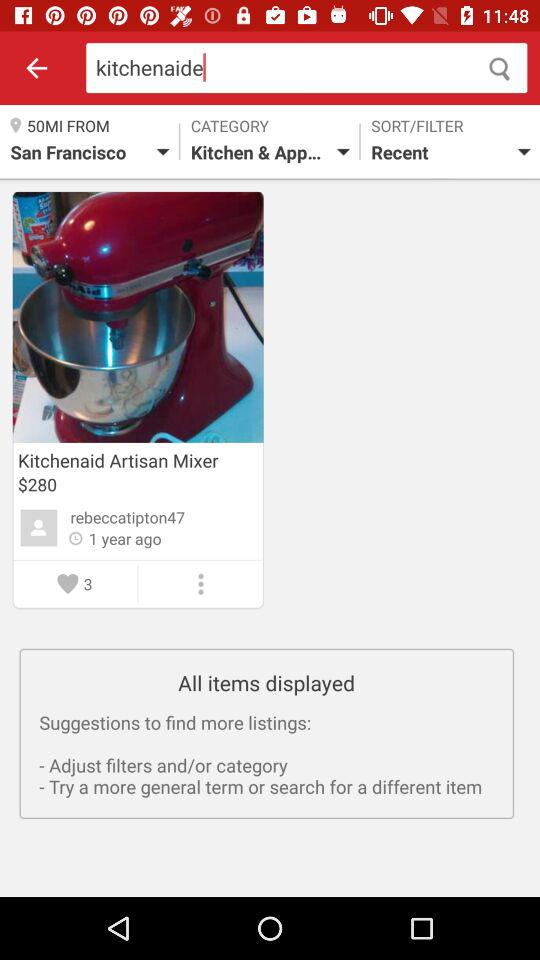How many people have liked the kitchenaid artisan mixer?
Answer the question using a single word or phrase. 3 